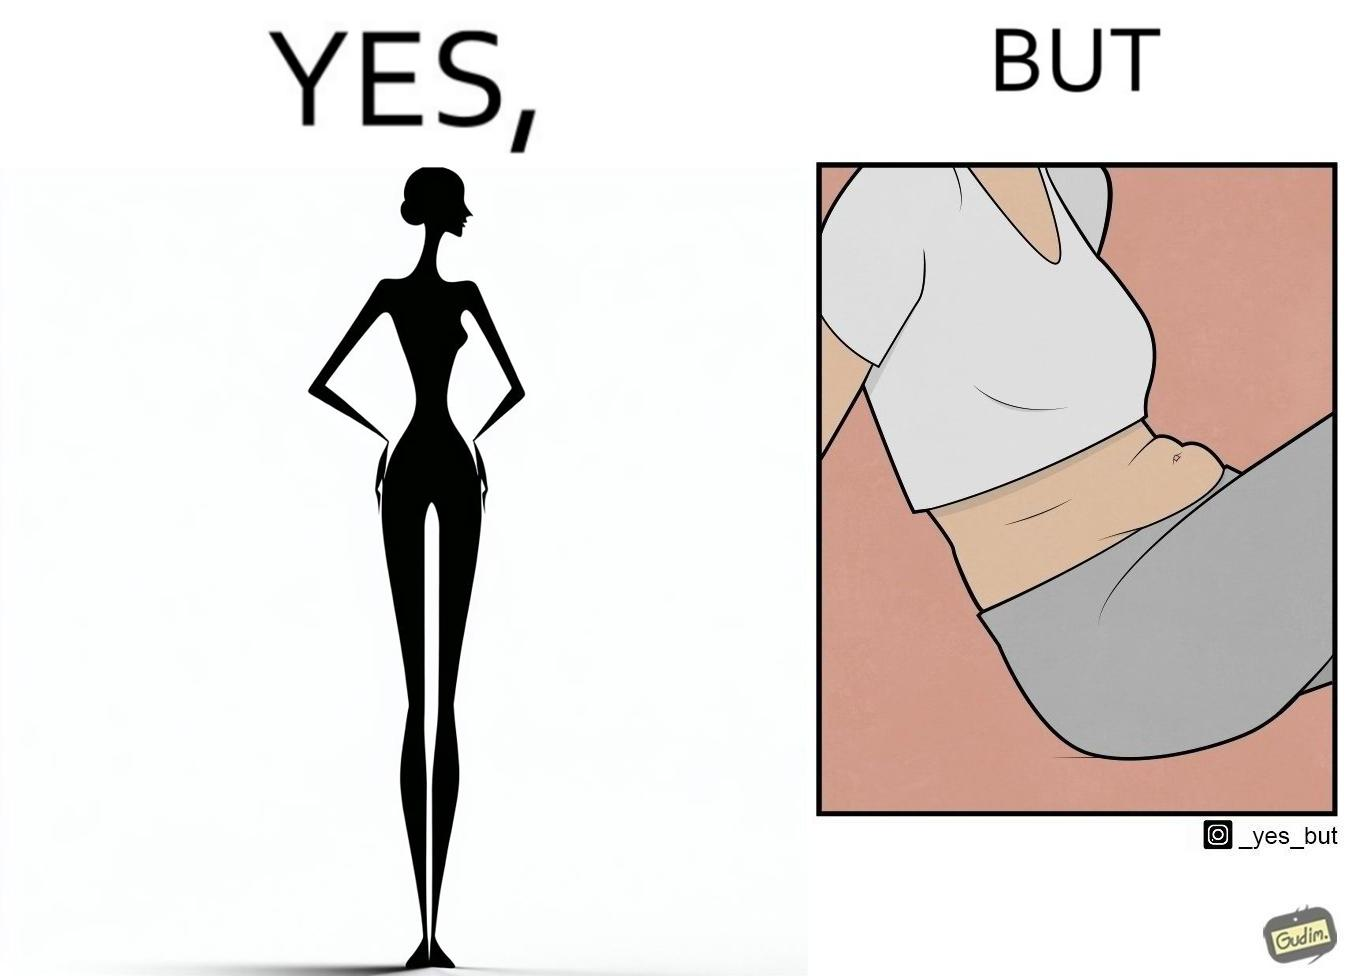Compare the left and right sides of this image. In the left part of the image: a slim woman In the right part of the image: An apparently chubby woman sitting 